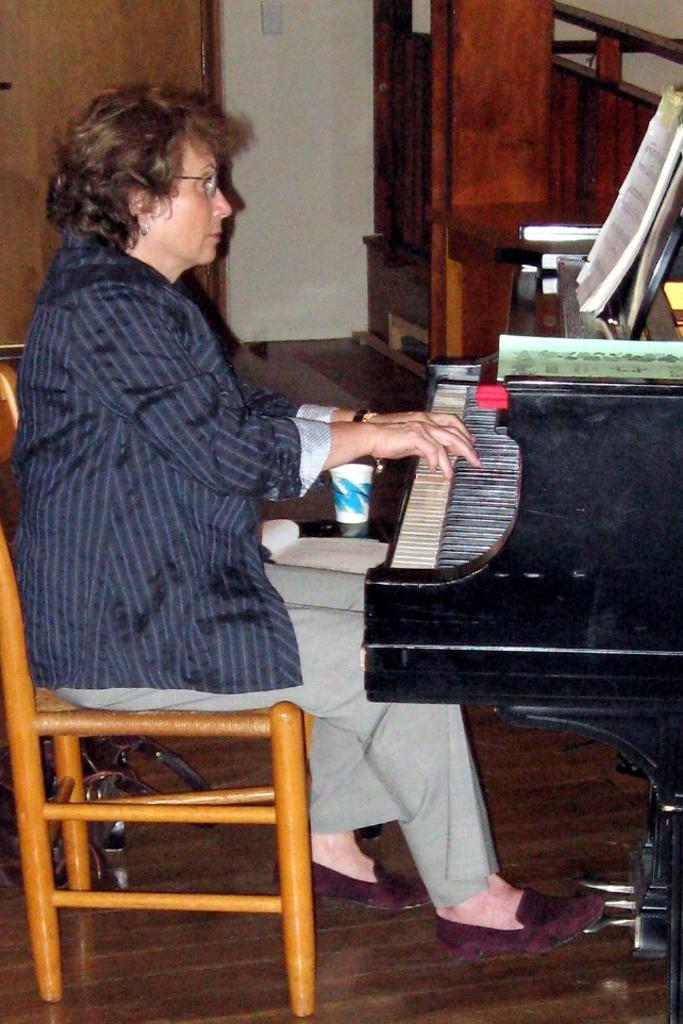Who is the main subject in the image? There is a woman in the image. What is the woman doing in the image? The woman is playing a musical instrument. What is the woman's position in the image? The woman is sitting on a chair. What type of health issues does the woman have in the image? There is no information about the woman's health in the image. Can you see a cannon in the image? No, there is no cannon present in the image. 